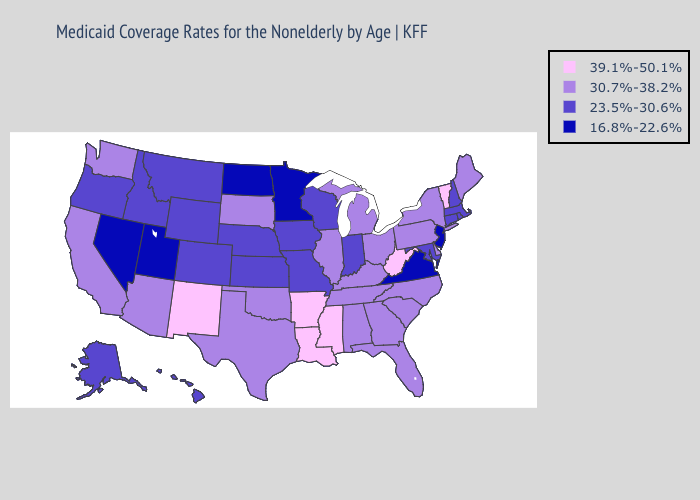Name the states that have a value in the range 39.1%-50.1%?
Keep it brief. Arkansas, Louisiana, Mississippi, New Mexico, Vermont, West Virginia. Does California have a lower value than Michigan?
Keep it brief. No. What is the value of Missouri?
Answer briefly. 23.5%-30.6%. Among the states that border Washington , which have the highest value?
Quick response, please. Idaho, Oregon. Name the states that have a value in the range 23.5%-30.6%?
Keep it brief. Alaska, Colorado, Connecticut, Hawaii, Idaho, Indiana, Iowa, Kansas, Maryland, Massachusetts, Missouri, Montana, Nebraska, New Hampshire, Oregon, Rhode Island, Wisconsin, Wyoming. What is the value of Montana?
Short answer required. 23.5%-30.6%. What is the highest value in the South ?
Write a very short answer. 39.1%-50.1%. What is the value of Indiana?
Short answer required. 23.5%-30.6%. Does Montana have the same value as Arkansas?
Keep it brief. No. What is the value of Wyoming?
Be succinct. 23.5%-30.6%. Name the states that have a value in the range 39.1%-50.1%?
Concise answer only. Arkansas, Louisiana, Mississippi, New Mexico, Vermont, West Virginia. What is the value of Illinois?
Give a very brief answer. 30.7%-38.2%. Name the states that have a value in the range 39.1%-50.1%?
Give a very brief answer. Arkansas, Louisiana, Mississippi, New Mexico, Vermont, West Virginia. How many symbols are there in the legend?
Answer briefly. 4. Does Georgia have a lower value than West Virginia?
Keep it brief. Yes. 